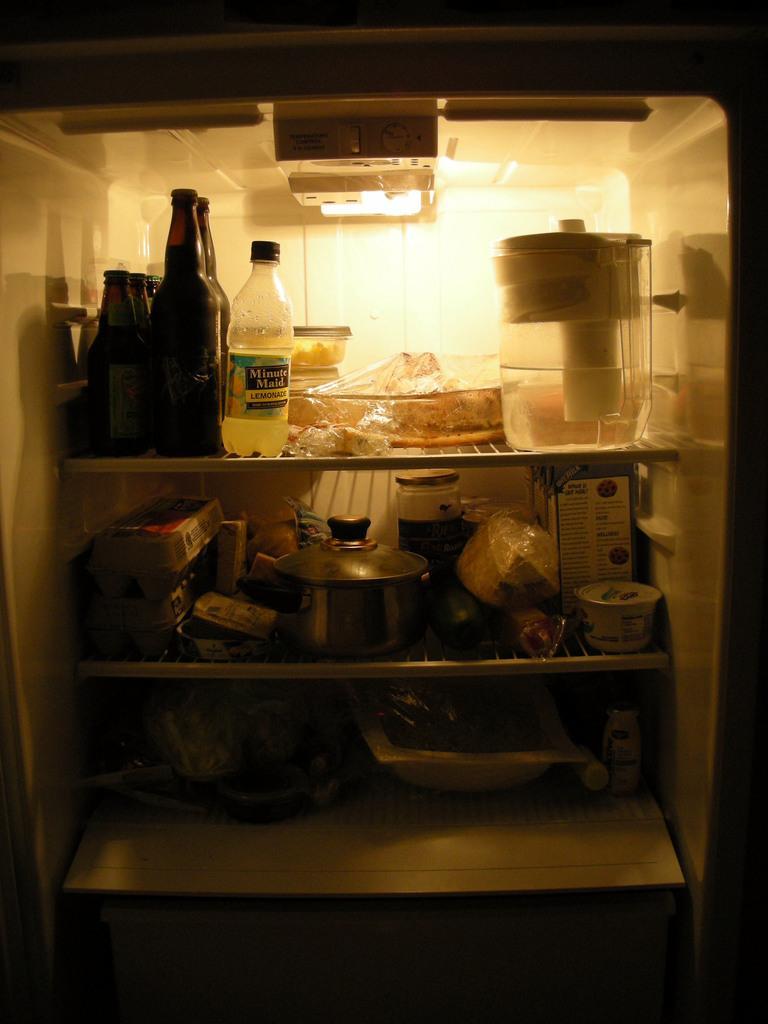Please provide a concise description of this image. In the give image we can see a fridge inside it bottles are kept. This is a steel pot. 